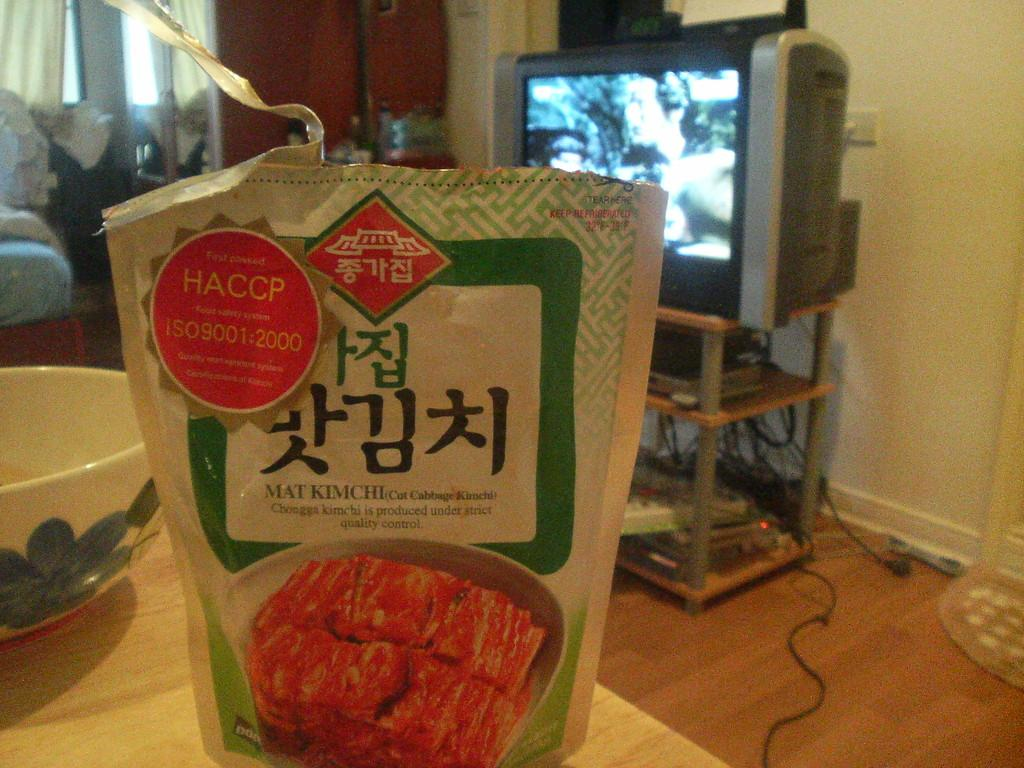<image>
Write a terse but informative summary of the picture. A package of some sort of food covered in foreign characters that says HACCP on it. 